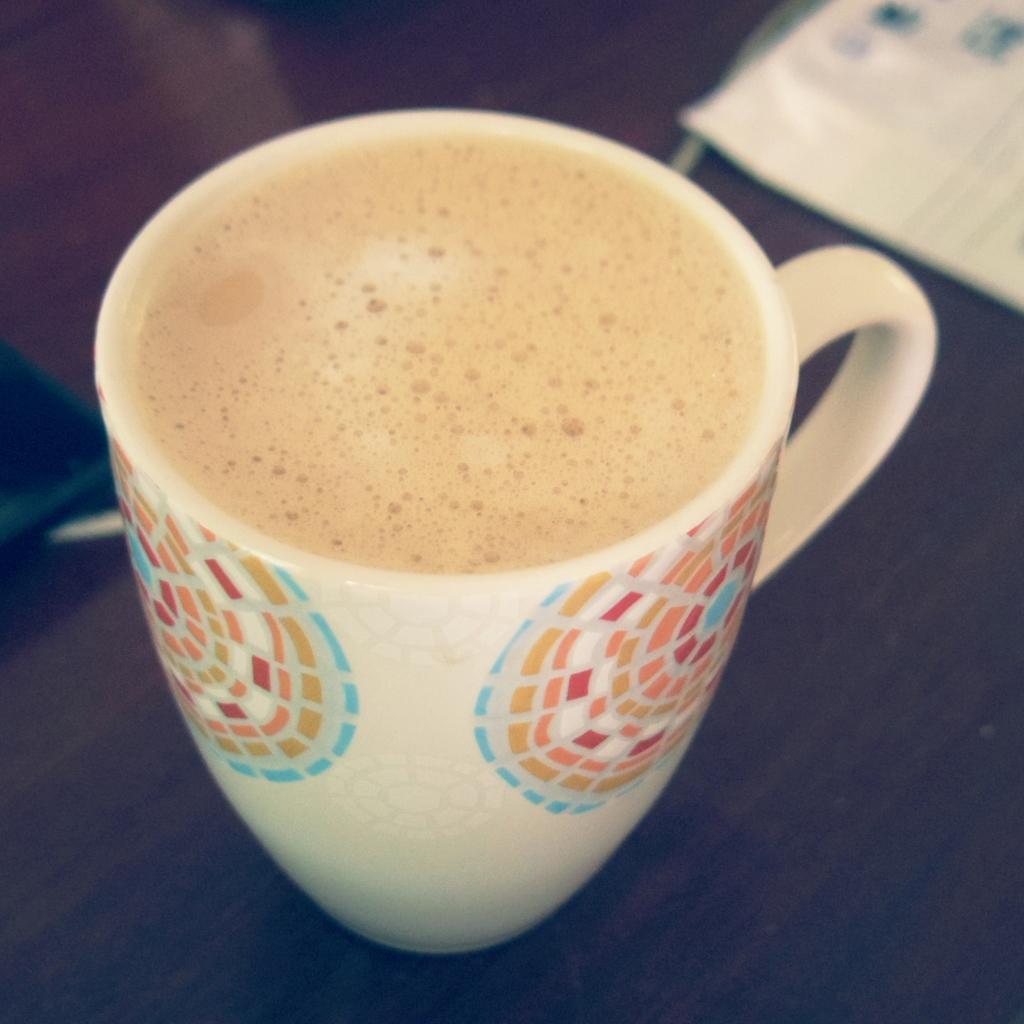Could you give a brief overview of what you see in this image? In this image we can see a cup of beverage placed on the table. 